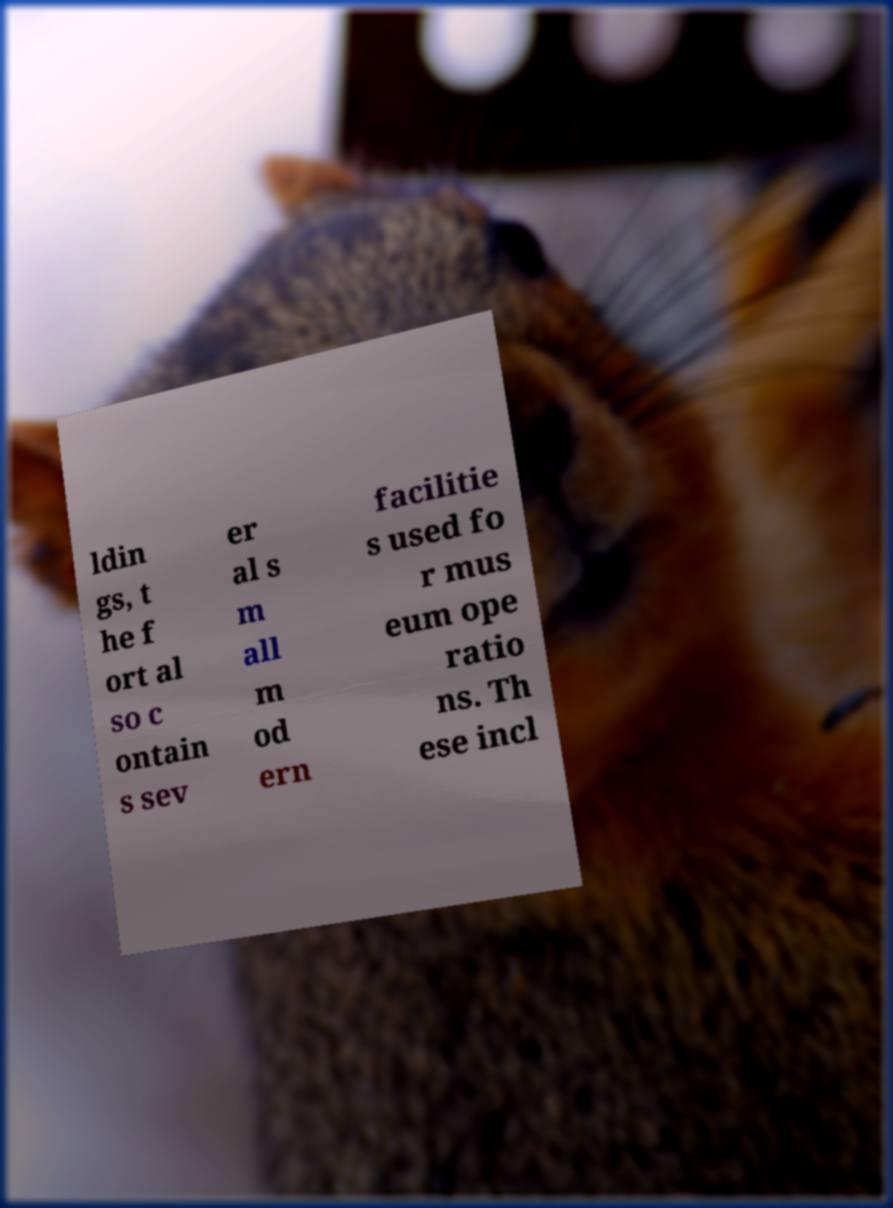Could you assist in decoding the text presented in this image and type it out clearly? ldin gs, t he f ort al so c ontain s sev er al s m all m od ern facilitie s used fo r mus eum ope ratio ns. Th ese incl 